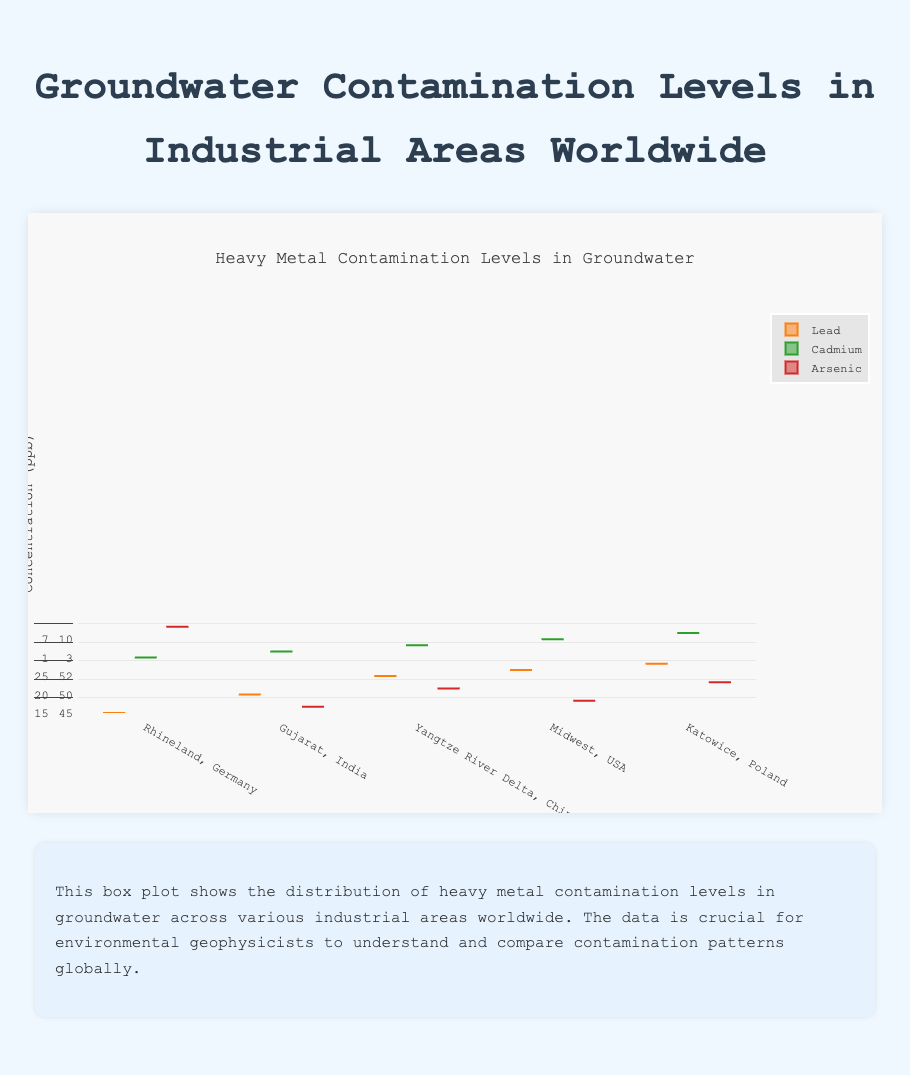What is the title of the figure? The title of the figure is displayed at the top and is a descriptive text summarizing the content of the figure.
Answer: Heavy Metal Contamination Levels in Groundwater Which region has the highest median concentration of lead? By examining the box plots for lead, the median is indicated by the line inside the box. The highest median line for lead is located in Gujarat, India.
Answer: Gujarat, India What is the maximum concentration of cadmium in the Midwest, USA? The maximum concentration in a box plot is represented by the upper whisker. For cadmium in the Midwest, USA, this value is at the highest point of the whisker.
Answer: 14 ppb Compare the median arsenic concentration levels between Rhineland, Germany and Gujarat, India. Which is higher? To compare, look at the median lines inside the boxes for arsenic in both regions. Gujarat, India has a higher median (38 ppb) than Rhineland, Germany (15 ppb).
Answer: Gujarat, India How does the interquartile range (IQR) of lead concentration in Katowice, Poland compare to that in Rhineland, Germany? The IQR is represented by the length of the box. For Katowice, Poland, the box spans from 40 to 50 (IQR of 10 ppb), while for Rhineland, Germany, the box spans from 20 to 35 (IQR of 15 ppb).
Answer: Rhineland, Germany has a larger IQR What is the difference between the highest cadmium concentration in Gujarat, India and the lowest cadmium concentration in the Midwest, USA? The highest cadmium concentration in Gujarat, India is represented by the upper whisker (15 ppb), and the lowest in the Midwest, USA is represented by the lower whisker (5 ppb). The difference is 15 - 5 = 10 ppb.
Answer: 10 ppb Which region has the widest spread in lead concentration levels? The widest spread (range) is determined by the distance between the smallest and largest values within the whiskers for each box plot. Gujarat, India has the widest spread for lead with values ranging from about 45 to 60 ppb.
Answer: Gujarat, India What is the median concentration of cadmium in Yangtze River Delta, China? The median concentration is indicated by the horizontal line inside the box for cadmium in Yangtze River Delta, China. It is at 9 ppb.
Answer: 9 ppb Is the concentration of arsenic in Rhineland, Germany ever higher than the maximum concentration of arsenic in Midwest, USA? By comparing the highest whisker in Rhineland, Germany (25 ppb) with the highest whisker in Midwest, USA (22 ppb), it is evident that the arsenic concentration in Rhineland, Germany can be higher.
Answer: Yes 